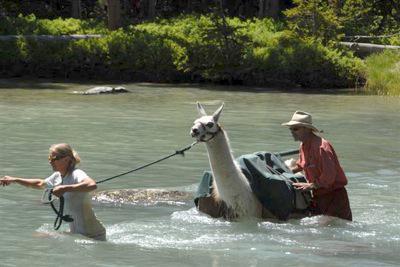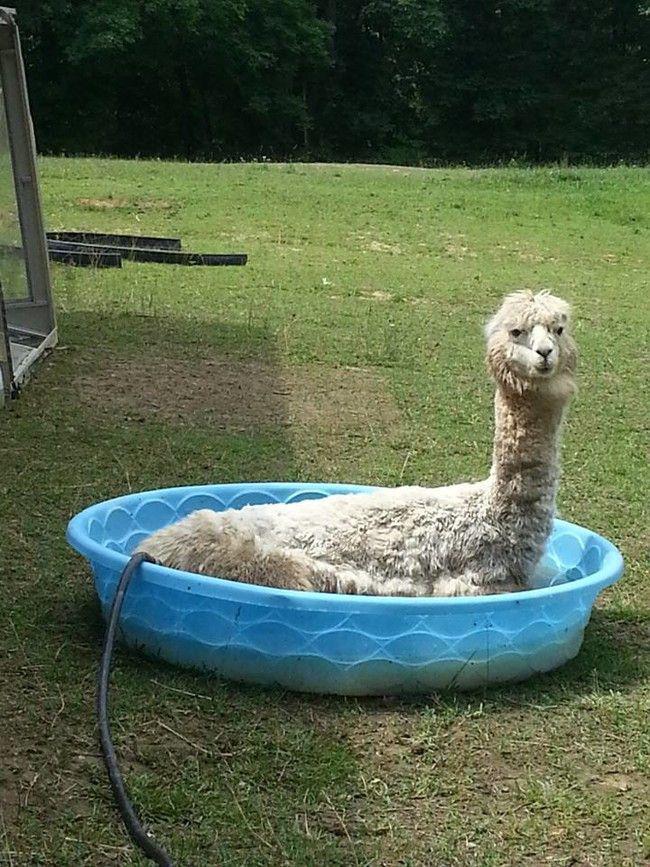The first image is the image on the left, the second image is the image on the right. Assess this claim about the two images: "An alpaca is laying down in a small blue pool in one of the pictures.". Correct or not? Answer yes or no. Yes. The first image is the image on the left, the second image is the image on the right. For the images displayed, is the sentence "One of the images shows an alpaca in a kiddie pool and the other image shows a llama in a lake." factually correct? Answer yes or no. Yes. 